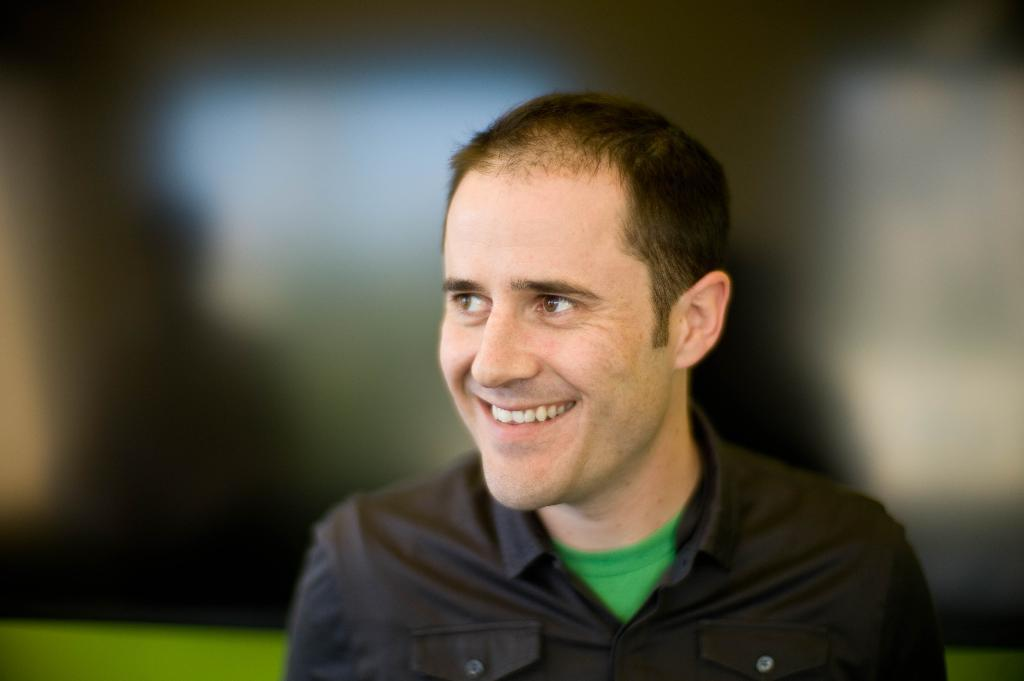What is the main subject of the image? There is a person in the image. What is the person's facial expression? The person is smiling. Can you describe the background of the image? The background of the image is blurred. What type of punishment is the owl administering to the person in the image? There is no owl present in the image, and therefore no punishment is being administered. 